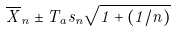Convert formula to latex. <formula><loc_0><loc_0><loc_500><loc_500>\overline { X } _ { n } \pm T _ { a } s _ { n } \sqrt { 1 + ( 1 / n ) }</formula> 